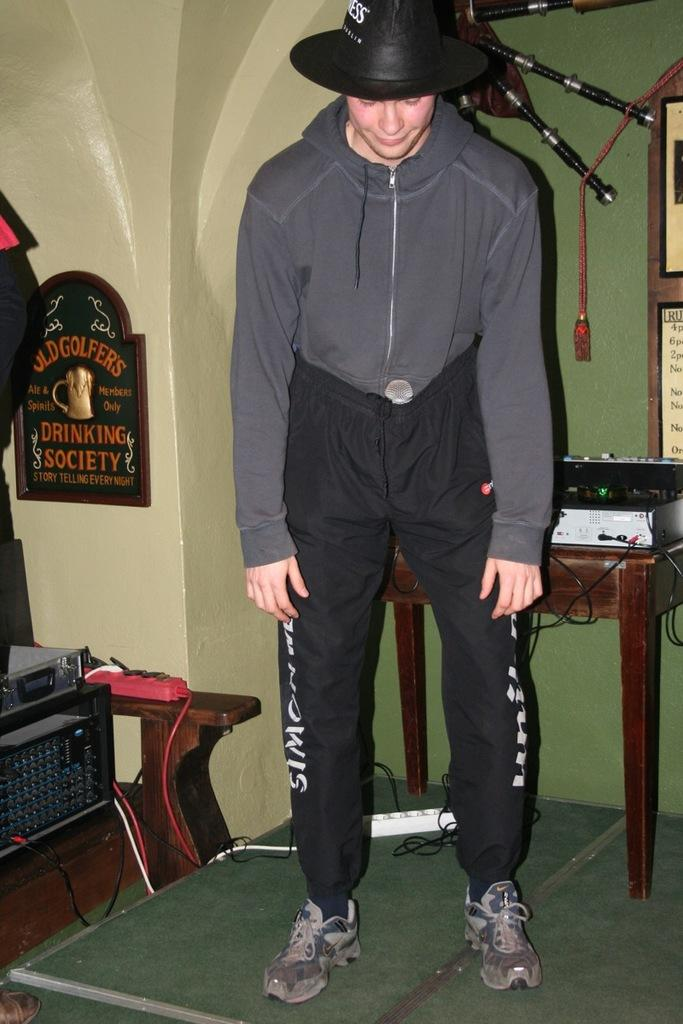Who is present in the image? There is a man in the image. What is the man doing in the image? The man is standing in the image. What is the man wearing on his head? The man is wearing a black cap in the image. What can be seen on the table in the image? There is a machine on a table in the image. How many houses can be seen behind the man in the image? There are no houses visible in the image; it only shows a man standing and a machine on a table. 